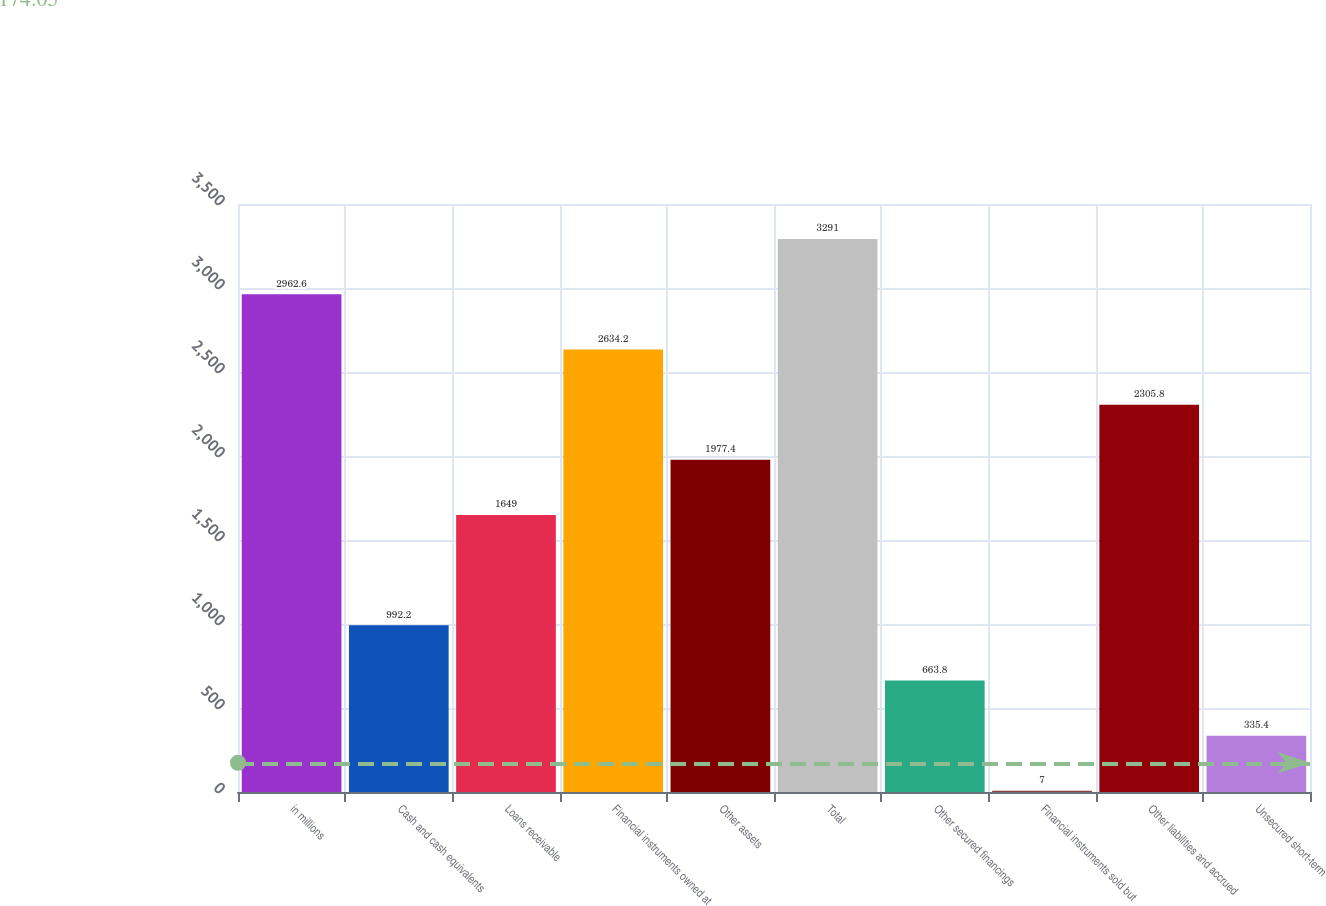Convert chart to OTSL. <chart><loc_0><loc_0><loc_500><loc_500><bar_chart><fcel>in millions<fcel>Cash and cash equivalents<fcel>Loans receivable<fcel>Financial instruments owned at<fcel>Other assets<fcel>Total<fcel>Other secured financings<fcel>Financial instruments sold but<fcel>Other liabilities and accrued<fcel>Unsecured short-term<nl><fcel>2962.6<fcel>992.2<fcel>1649<fcel>2634.2<fcel>1977.4<fcel>3291<fcel>663.8<fcel>7<fcel>2305.8<fcel>335.4<nl></chart> 